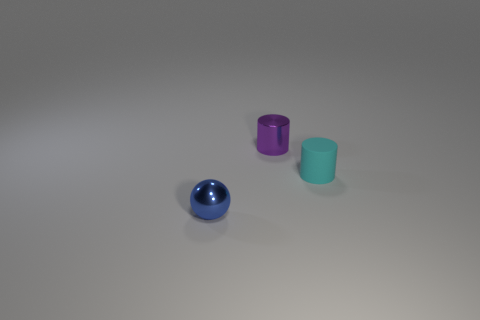What number of objects are metallic things or small matte spheres?
Offer a very short reply. 2. There is a metallic object that is right of the tiny thing that is in front of the cyan cylinder; how many purple things are in front of it?
Your answer should be compact. 0. Are there any other things of the same color as the matte thing?
Your answer should be compact. No. There is a small metal object on the right side of the blue metal object; is it the same color as the tiny cylinder right of the purple shiny cylinder?
Your response must be concise. No. Are there more cyan rubber things to the right of the rubber thing than tiny matte cylinders behind the small blue metallic object?
Keep it short and to the point. No. What is the cyan cylinder made of?
Make the answer very short. Rubber. What shape is the tiny metal thing on the right side of the small metal thing that is in front of the tiny metallic object behind the tiny cyan cylinder?
Ensure brevity in your answer.  Cylinder. How many other objects are there of the same material as the tiny purple cylinder?
Give a very brief answer. 1. Is the material of the tiny object to the right of the purple metal thing the same as the object that is left of the purple thing?
Keep it short and to the point. No. How many small objects are both on the left side of the tiny metal cylinder and behind the ball?
Keep it short and to the point. 0. 